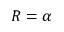<formula> <loc_0><loc_0><loc_500><loc_500>R = \alpha</formula> 